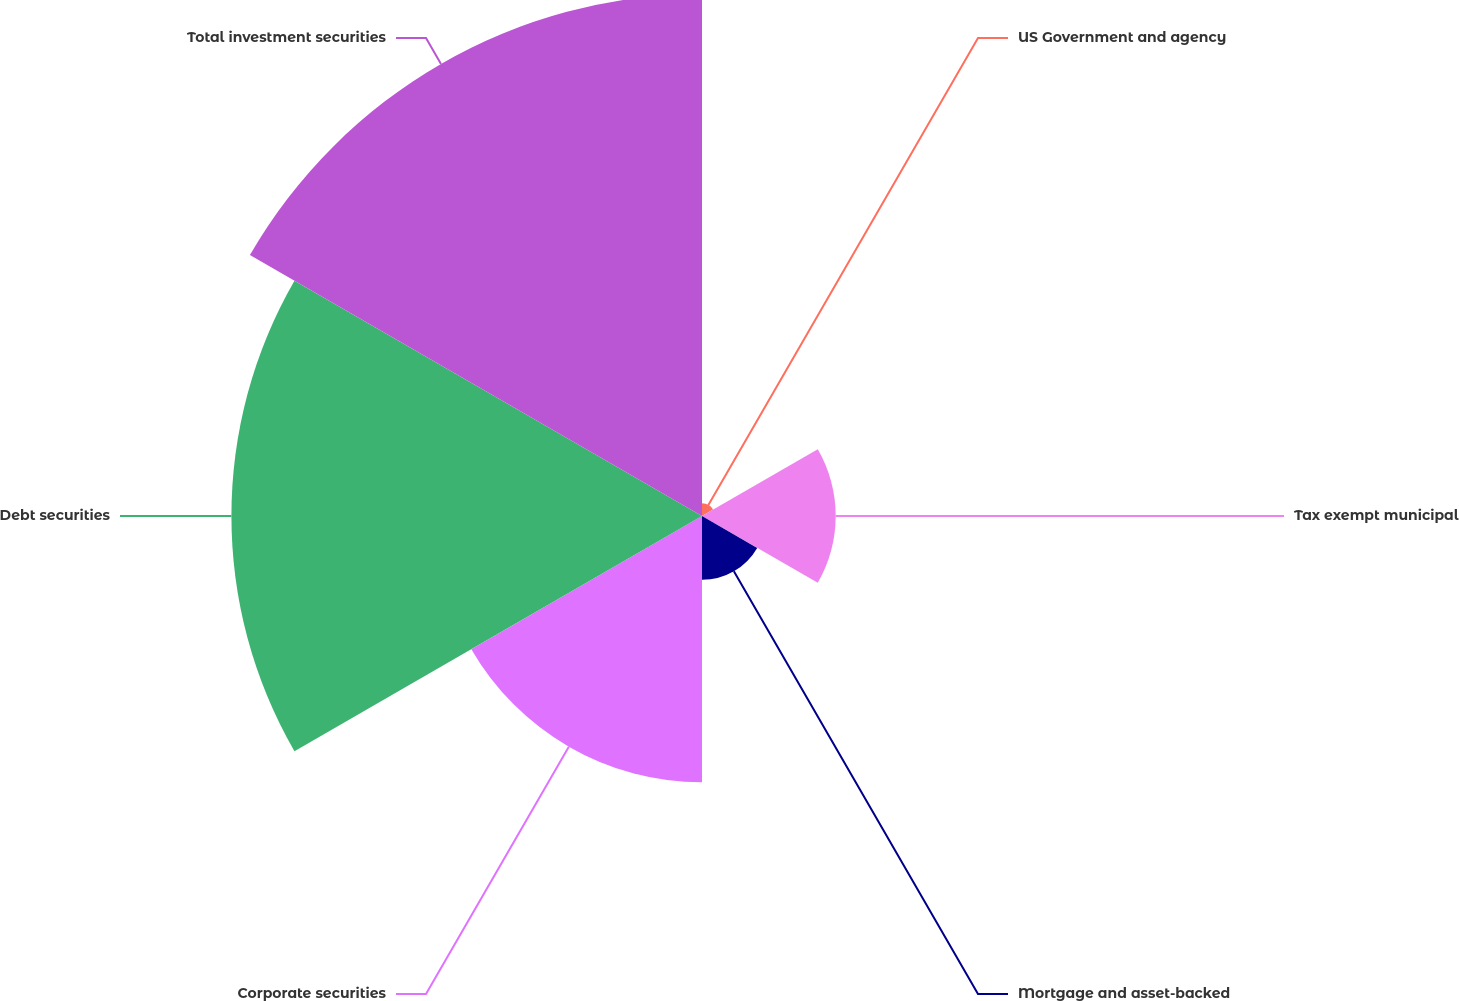Convert chart to OTSL. <chart><loc_0><loc_0><loc_500><loc_500><pie_chart><fcel>US Government and agency<fcel>Tax exempt municipal<fcel>Mortgage and asset-backed<fcel>Corporate securities<fcel>Debt securities<fcel>Total investment securities<nl><fcel>0.87%<fcel>9.1%<fcel>4.34%<fcel>18.13%<fcel>32.03%<fcel>35.53%<nl></chart> 